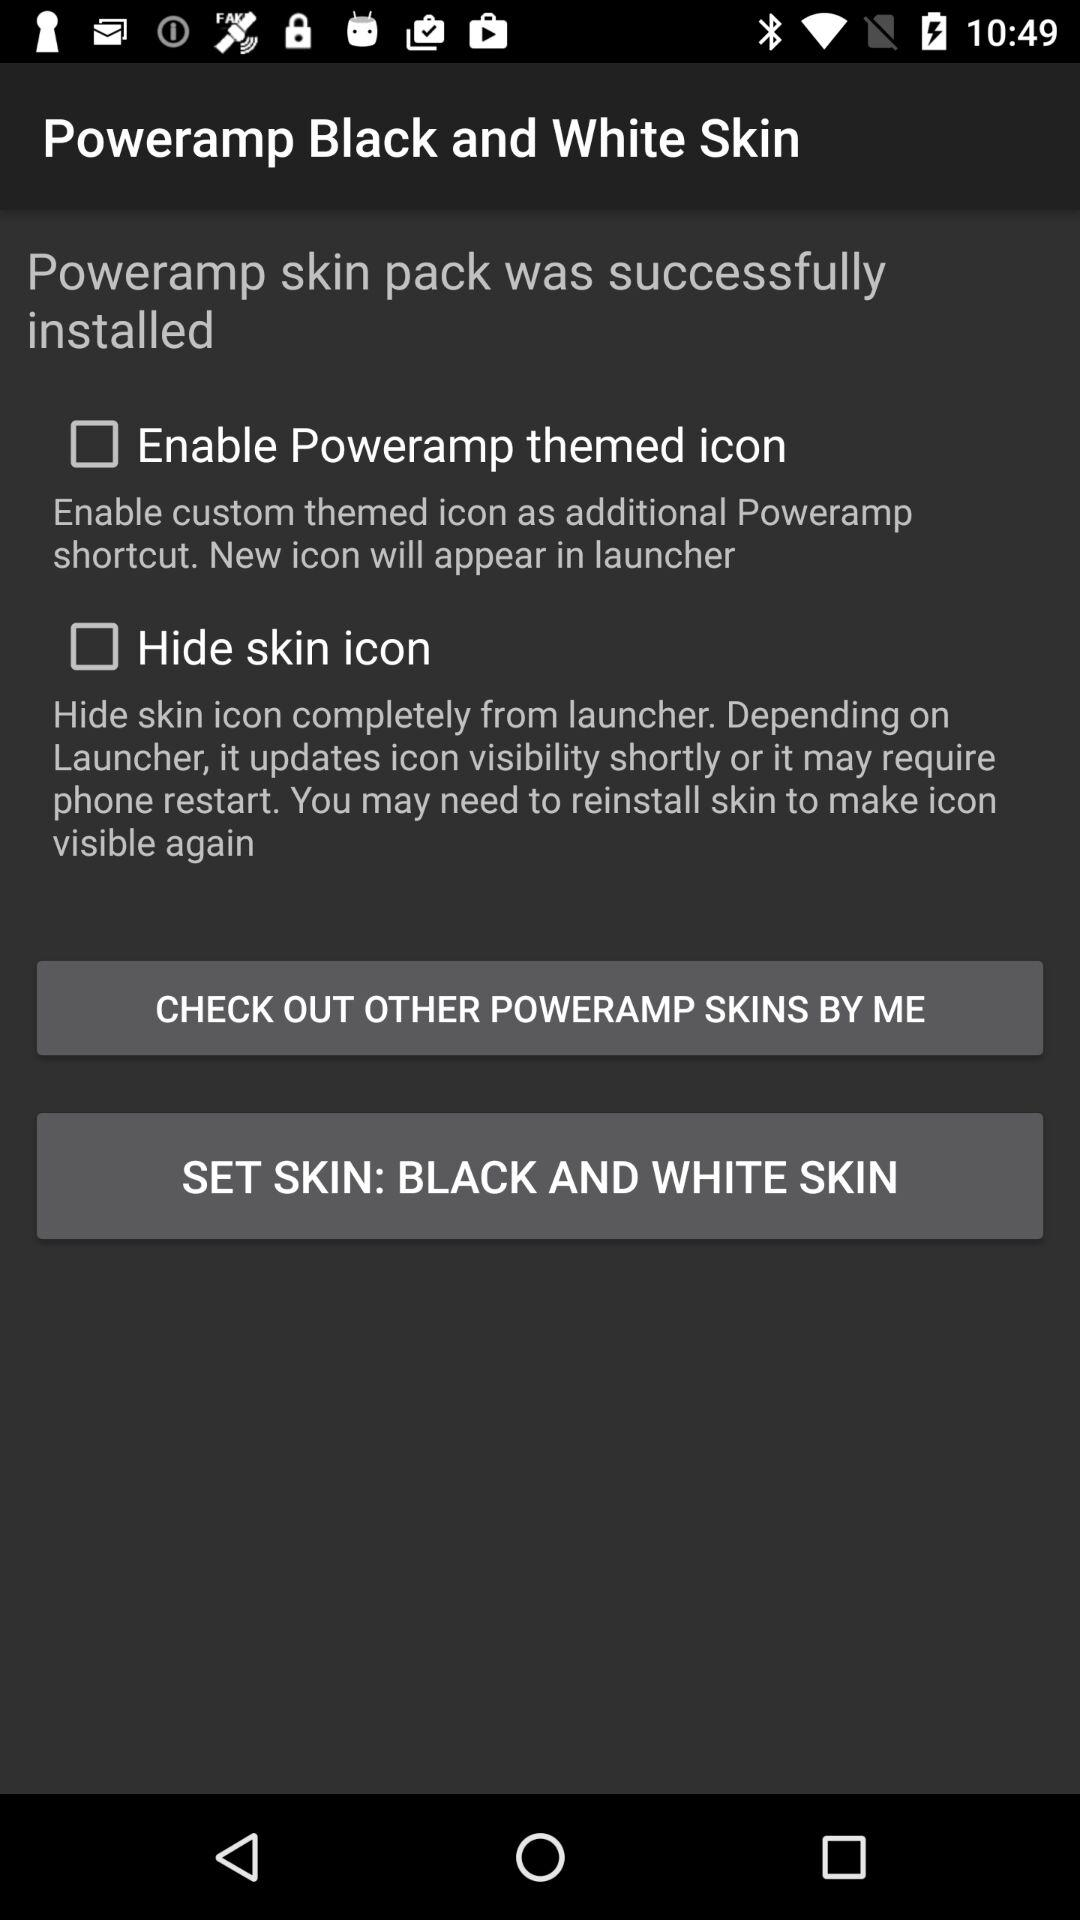What is the status of the hide skin icon? The status of the hide skin icon is "off". 